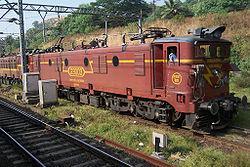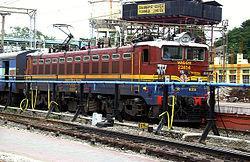The first image is the image on the left, the second image is the image on the right. Analyze the images presented: Is the assertion "An image shows a train with stripes of blue on the bottom, followed by red, white, red, and white on top." valid? Answer yes or no. No. The first image is the image on the left, the second image is the image on the right. Given the left and right images, does the statement "Each of the images shows a train pointed in the same direction." hold true? Answer yes or no. Yes. 